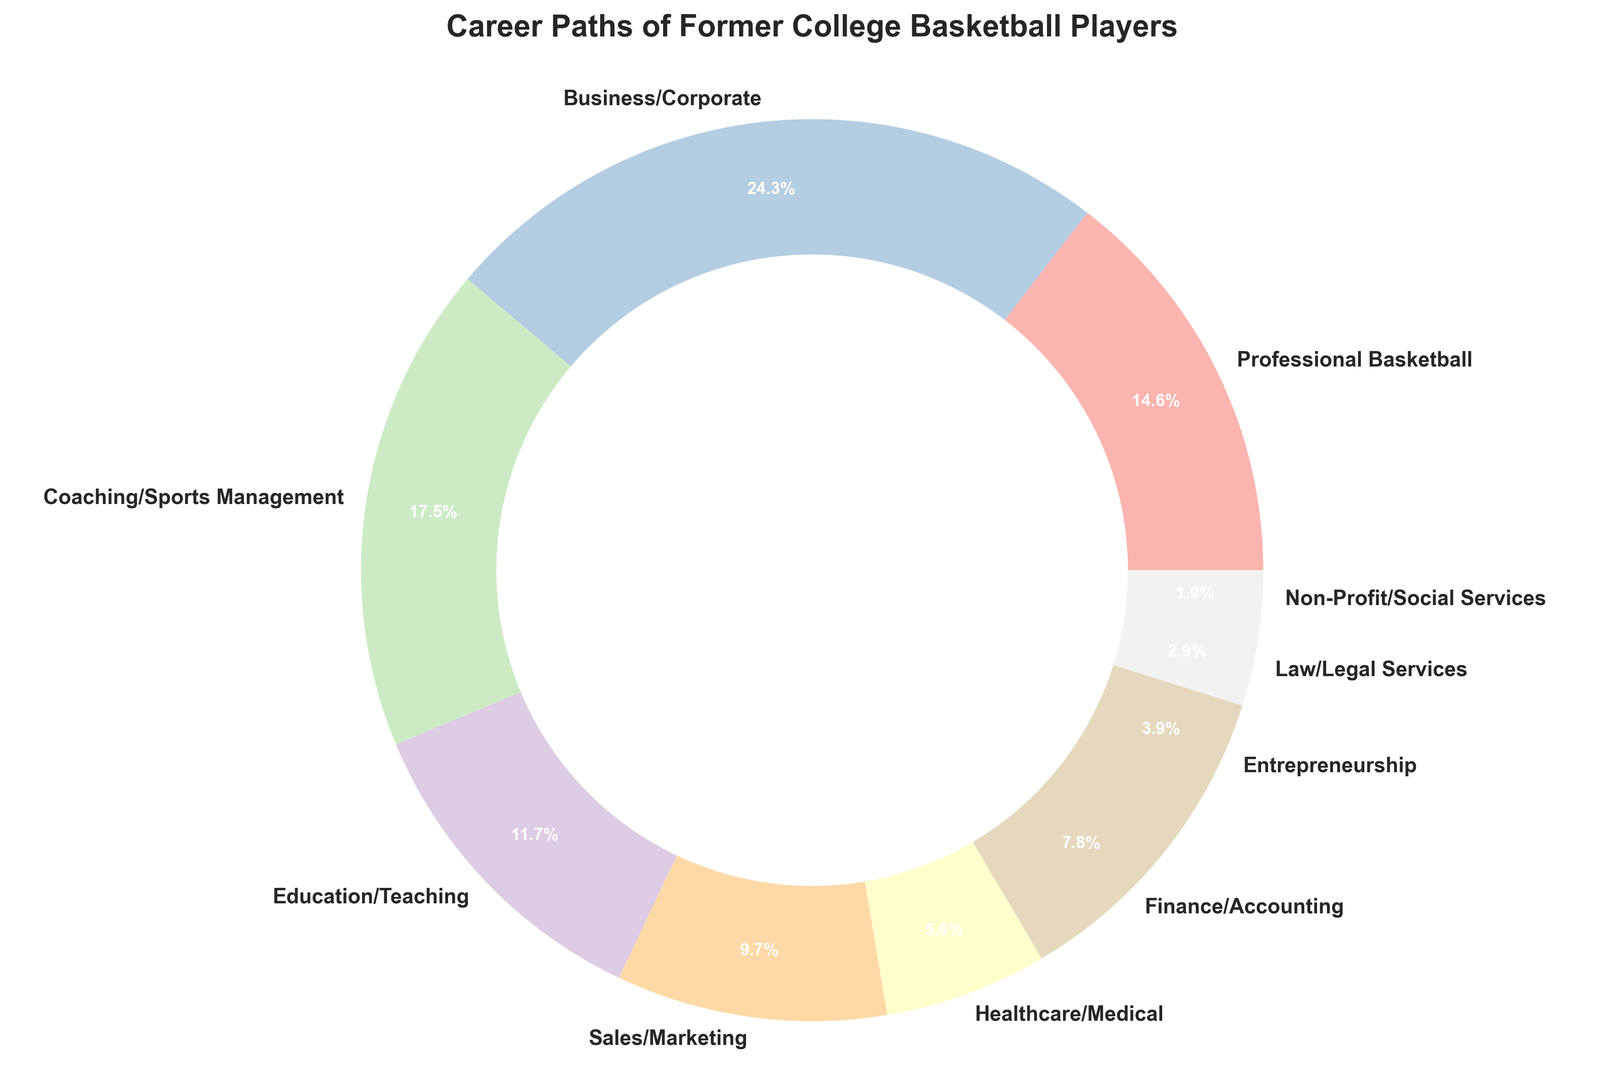which career path has the highest percentage of former college basketball players? The pie chart shows that the category "Business/Corporate" has the highest percentage. By looking at the segments, we can see that Business/Corporate has the largest portion.
Answer: Business/Corporate What is the combined percentage of former college basketball players working in Education/Teaching and Sales/Marketing? Add the percentages of Education/Teaching (12%) and Sales/Marketing (10%). Therefore, 12% + 10% = 22%.
Answer: 22% Which career paths have a percentage less than 5%? By examining the pie chart, the segments for Entrepreneurship (4%), Law/Legal Services (3%), and Non-Profit/Social Services (2%) are all less than 5%.
Answer: Entrepreneurship, Law/Legal Services, Non-Profit/Social Services How many career paths have percentages greater than that of Finance/Accounting? Finance/Accounting has a percentage of 8%. By inspecting the chart, Business/Corporate (25%), Coaching/Sports Management (18%), Education/Teaching (12%), Professional Basketball (15%), and Sales/Marketing (10%) all have percentages greater than 8%. Thus, 5 career paths have percentages greater than Finance/Accounting.
Answer: 5 What is the percentage difference between Coaching/Sports Management and Healthcare/Medical? Subtract the percentage of Healthcare/Medical (6%) from the percentage of Coaching/Sports Management (18%). Therefore, 18% - 6% = 12%.
Answer: 12% What color represents the Professional Basketball segment in the pie chart? The Professional Basketball segment corresponds to a specific color in the pie chart. By examining the visual attributes, we can identify that it is the first label in the legend, typically shown at the top right.
Answer: (Color of Professional Basketball segment, e.g., Pastel1 shade) Which two career paths combined make up one-fourth (25%) of the total? Look for two career paths whose combined total percentages equal 25%. Law/Legal Services (3%) and Healthcare/Medical (6%) do not fit the requirement. Next combination: Sales/Marketing (10%) and Education/Teaching (12%) also do not. The correct combination is Sales/Marketing (10%) and Finance/Accounting (8%) which total to 18%. Therefore, the combined percentage for Coaching/Sports Management (18%) and Non-Profit/Social Services (2%) equals 20%, still not fitting. Business/Corporate itself fits this requirement directly as it equals 25%. Therefore, only Business/Corporate meets the one-fourth requirement alone.
Answer: Business/Corporate+Law/Legal Services 